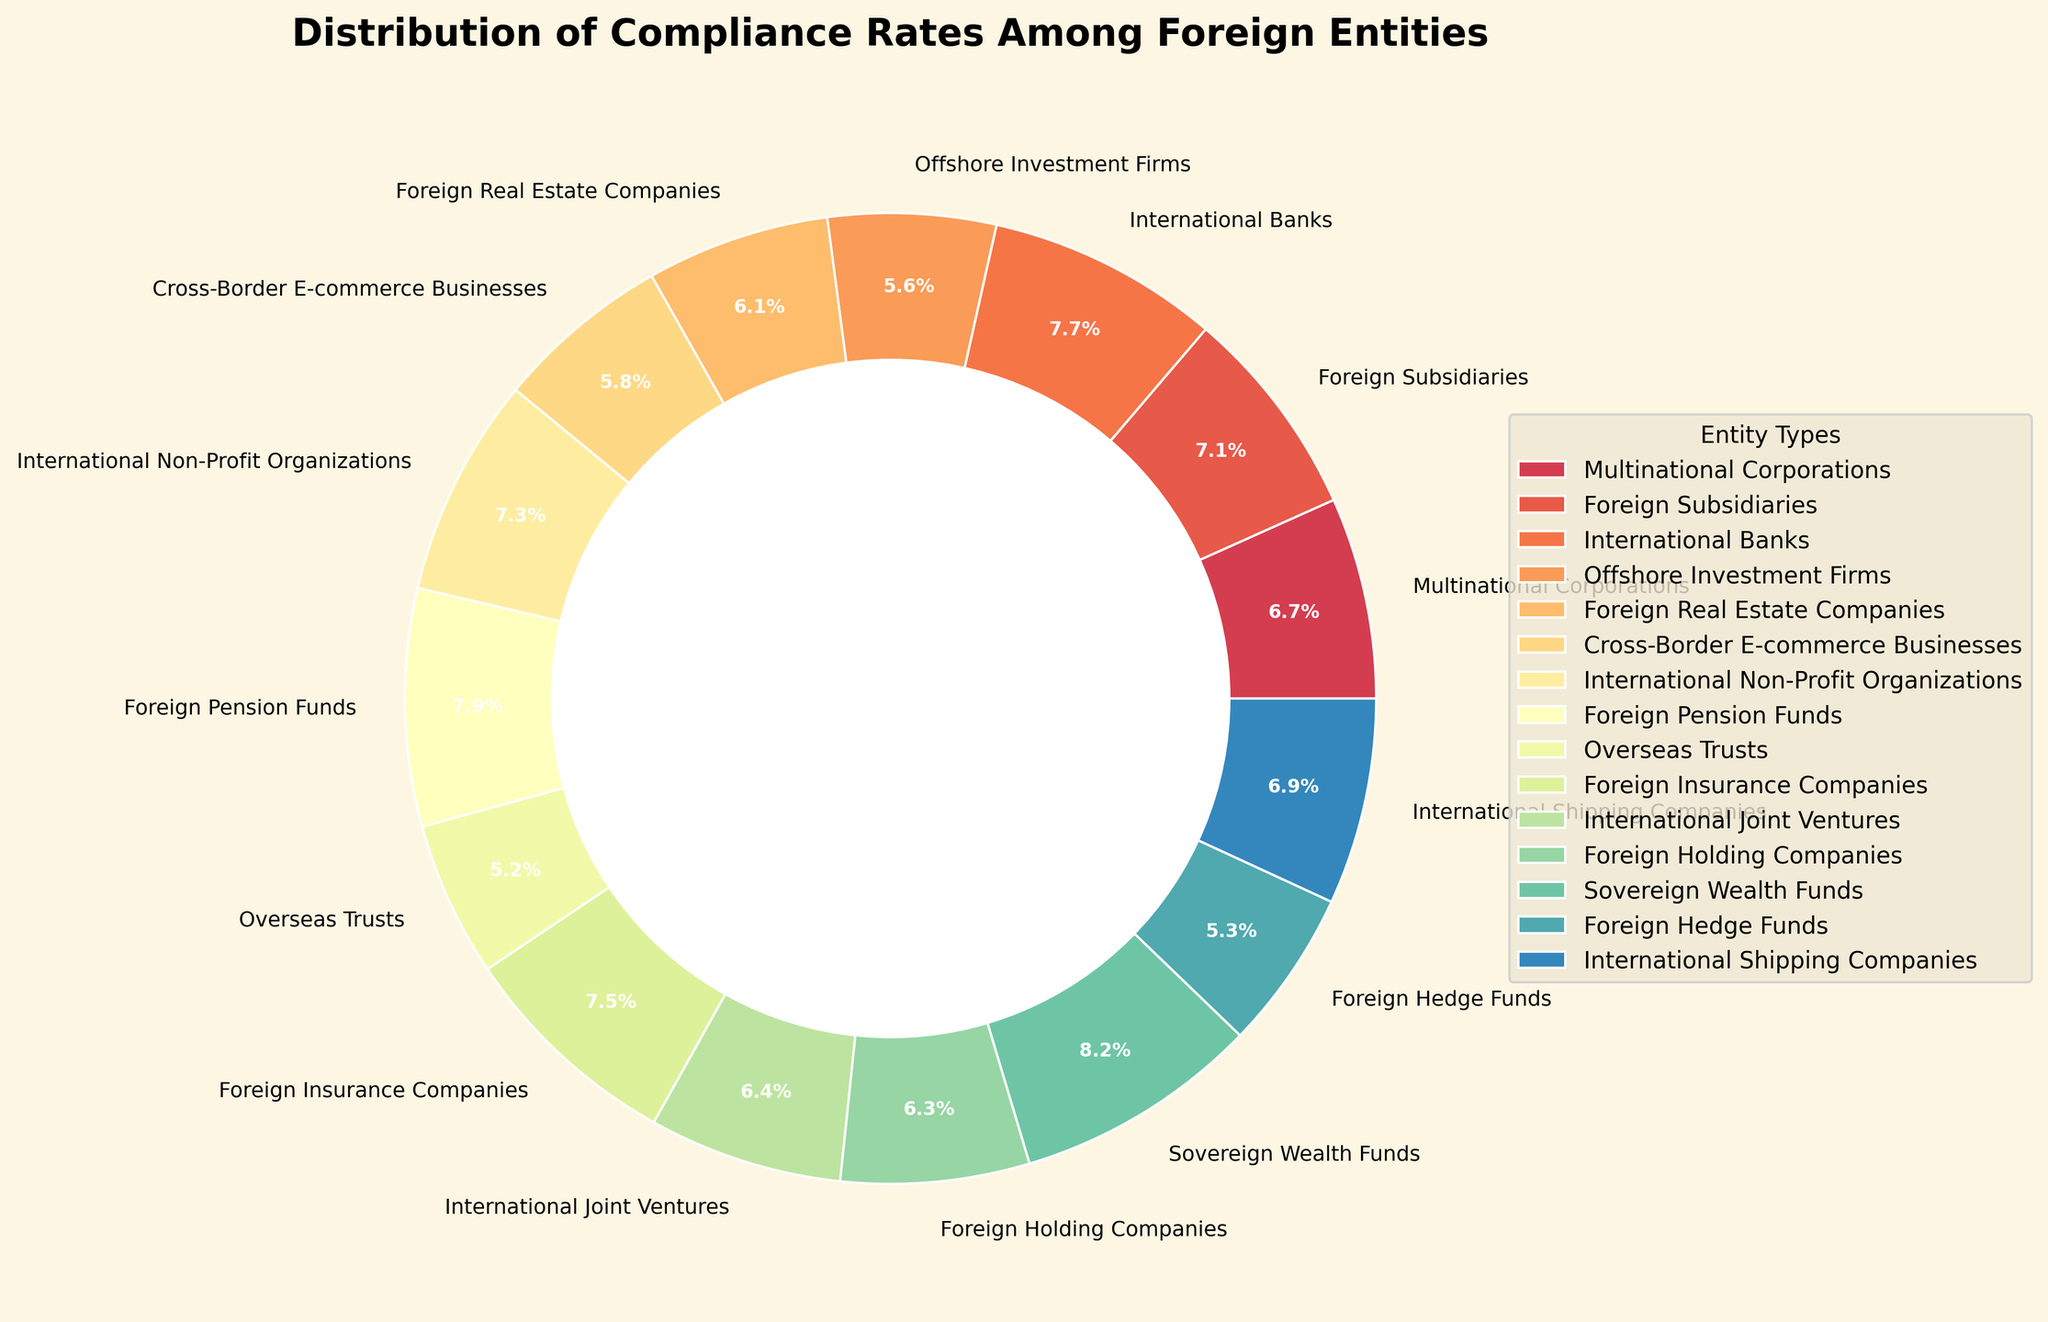Which entity type has the highest compliance rate? The chart shows the compliance rates for different foreign entity types. By observing the sizes of the pie slices and their labels, the slice labeled "Sovereign Wealth Funds" appears to be the largest, indicating the highest compliance rate.
Answer: Sovereign Wealth Funds How do the compliance rates of International Banks and Foreign Hedge Funds compare? The chart indicates that International Banks have a higher compliance rate than Foreign Hedge Funds by looking at their respective pie slice sizes and percentage labels. International Banks are 90%, while Foreign Hedge Funds are 62%.
Answer: International Banks > Foreign Hedge Funds What is the total compliance rate percentage for entities with a compliance rate of at least 85%? To find this, sum the compliance rates of entities with at least 85% compliance: International Banks (90%), International Non-Profit Organizations (85%), Foreign Pension Funds (92%), Foreign Insurance Companies (87%), Sovereign Wealth Funds (95%). Summing these gives (90 + 85 + 92 + 87 + 95).
Answer: 449% What is the difference in compliance rates between the highest and lowest compliance rate entities? The highest compliance rate is for Sovereign Wealth Funds at 95%, and the lowest is Overseas Trusts at 60%. The difference can be calculated as 95 - 60.
Answer: 35 Are there more entities with compliance rates above or below 75%? Count the number of entities with compliance rates above 75% (Multinational Corporations, Foreign Subsidiaries, International Banks, International Non-Profit Organizations, Foreign Pension Funds, Foreign Insurance Companies, Sovereign Wealth Funds, International Shipping Companies) and below 75% (Offshore Investment Firms, Foreign Real Estate Companies, Cross-Border E-commerce Businesses, Overseas Trusts, Foreign Hedge Funds, Foreign Holding Companies, International Joint Ventures). 8 entities have rates above 75% and 7 are below 75%.
Answer: More above 75% Which entity type has the third highest compliance rate? By examining the pie chart slices and their labels, the highest compliance rate belongs to Sovereign Wealth Funds (95%), the second highest to Foreign Pension Funds (92%), and the third highest to International Banks (90%).
Answer: International Banks What is the average compliance rate of Offshore Investment Firms, Cross-Border E-commerce Businesses, and International Shipping Companies? Add the compliance rates of these entities and divide by the number of entities. Compliance rates are Offshore Investment Firms (65%), Cross-Border E-commerce Businesses (68%), International Shipping Companies (80%). The calculation is (65 + 68 + 80) / 3.
Answer: 71% How do the compliance rates of Multinational Corporations and International Joint Ventures compare? Examine the pie slices for these entities. Multinational Corporations have a compliance rate of 78%, whereas International Joint Ventures have a compliance rate of 75%.
Answer: Multinational Corporations > International Joint Ventures 